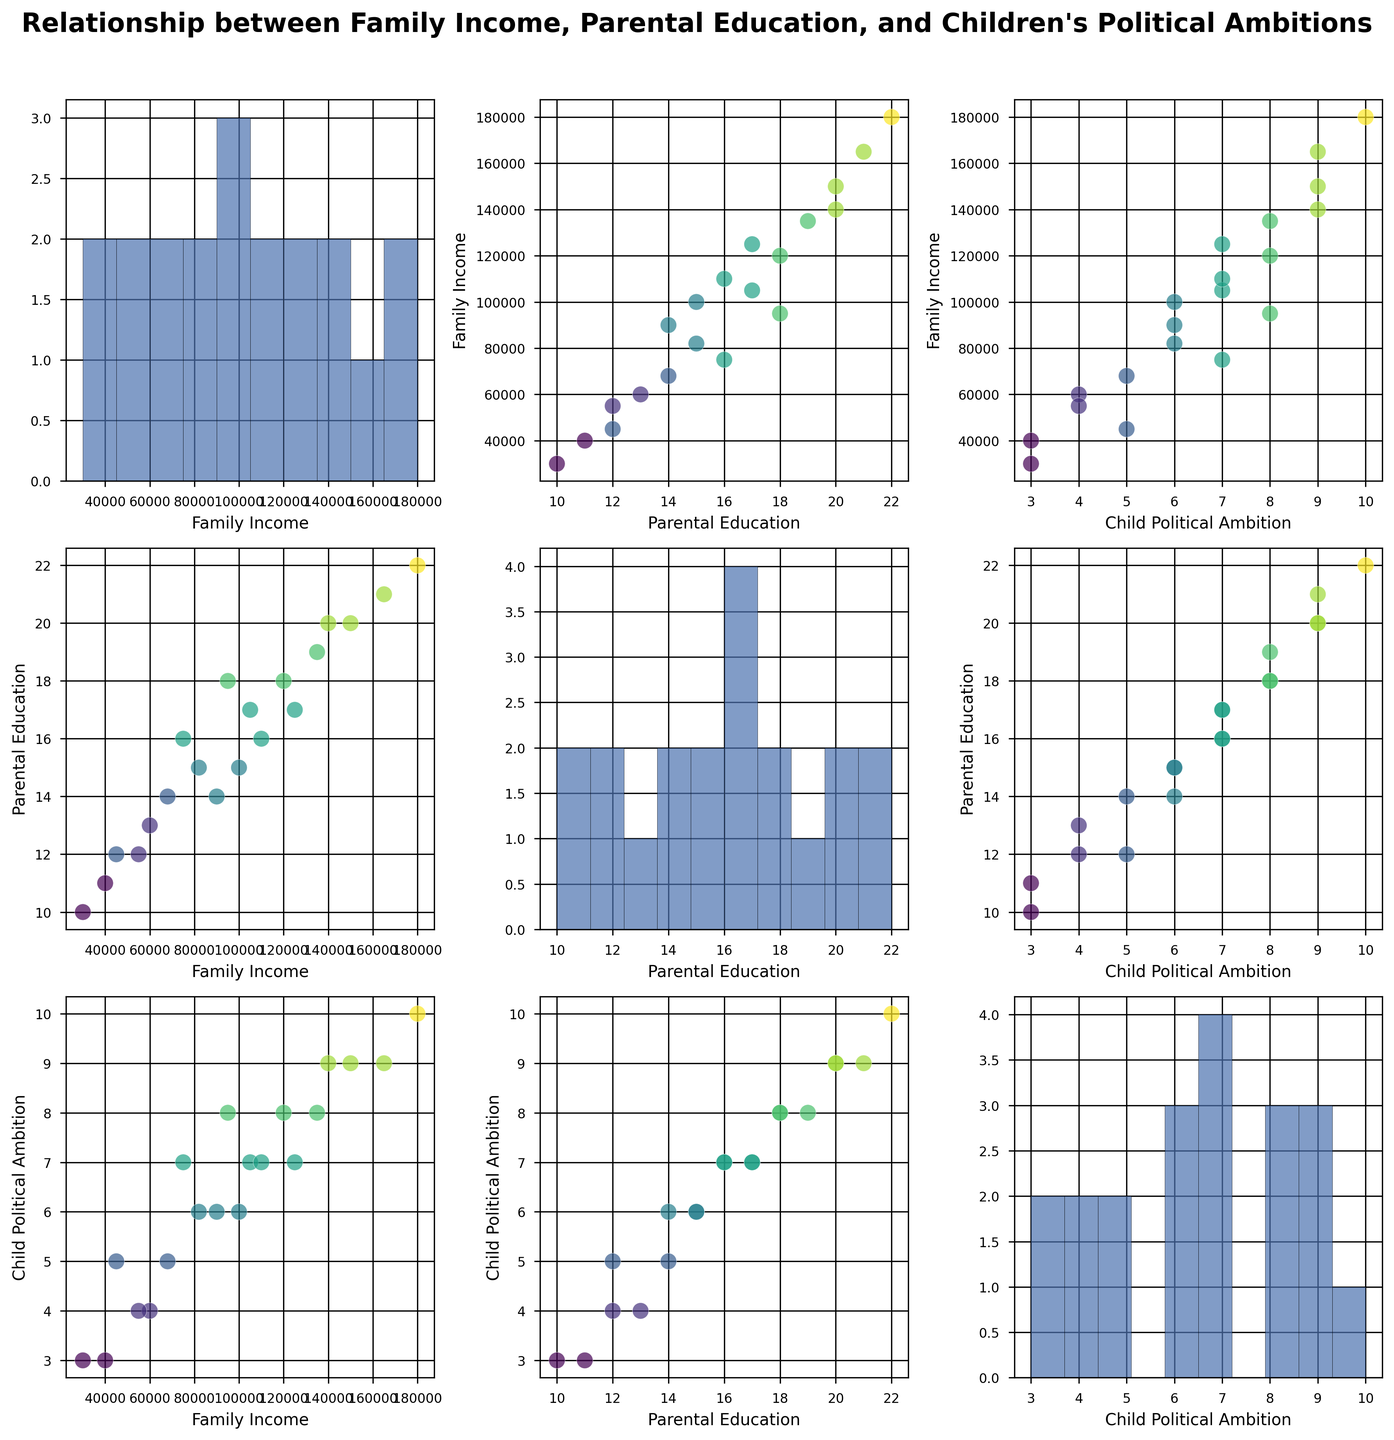What is the title of the figure? The title of the figure is usually at the top and describes the overall theme or purpose of the plot. In this case, it's located at the top of the scatterplot matrix.
Answer: Relationship between Family Income, Parental Education, and Children's Political Ambitions Which variable is displayed on the x-axis in the top-right scatterplot? In the scatterplot matrix, each column and row represent the same variable across different plots. The top-right scatterplot matches the first variable (Family Income) on the y-axis of the top row with the last variable (Child Political Ambition) on the x-axis of the last column.
Answer: Child Political Ambition How many data points are there in each scatterplot? Each scatterplot represents the same dataset with different variables compared against each other, so the number of data points is consistent across all scatterplots. Counting the points or referencing the given data (which has 20 rows) confirms the count.
Answer: 20 Is there a general trend between parental education and children's political ambitions? Observing the scatterplot where Parental Education is on one axis and Child Political Ambition on the other, we look for patterns or lines indicating relationships. The points generally trend upwards, suggesting a positive relationship.
Answer: Positive trend What is the range of family incomes represented in the histogram? The family income histogram in the diagonal shows the distribution of incomes. By observing the min and max values of the x-axis in this histogram, we get the range.
Answer: $30,000 to $180,000 How does an increase in family income generally affect children's political ambitions? By examining the scatterplot between Family Income and Child Political Ambition, we notice if points trend upwards or downwards as income increases. There's a general upwards trend, indicating that higher family income is associated with greater political ambitions among children.
Answer: Higher income generally leads to higher political ambitions Which parental education level has the highest concentration of data points? The histogram for Parental Education (diagonal) shows the frequency of each education level. The tallest bar represents the education level with the highest concentration.
Answer: 16 years Compare the relationship between family income and children's political ambitions to the relationship between parental education and children's political ambitions. Look at the scatterplots of Family Income vs. Child Political Ambition and Parental Education vs. Child Political Ambition. Both scatterplots show positive trends, but the scatterplot with Parental Education appears to have a clearer upward trend with less scatter.
Answer: Parental education shows a clearer positive relationship Are there any children's political ambition levels that appear frequently in the data, regardless of income or parental education? By examining the Child Political Ambition histograms (diagonal), we assess the frequency of each ambition level across the dataset. Peaks indicate frequent ambition levels.
Answer: Levels 7 and 8 appear frequently How does the spread of data points differ between the scatterplots of Family Income vs Parental Education and Parental Education vs Child Political Ambition? In Family Income vs. Parental Education scatterplot, the data may be widely spread due to variability in income and education levels. In Parental Education vs. Child Political Ambition, the spread is narrower, indicating a stronger, consistent relationship.
Answer: More spread in income vs. education, tighter in education vs. ambitions 